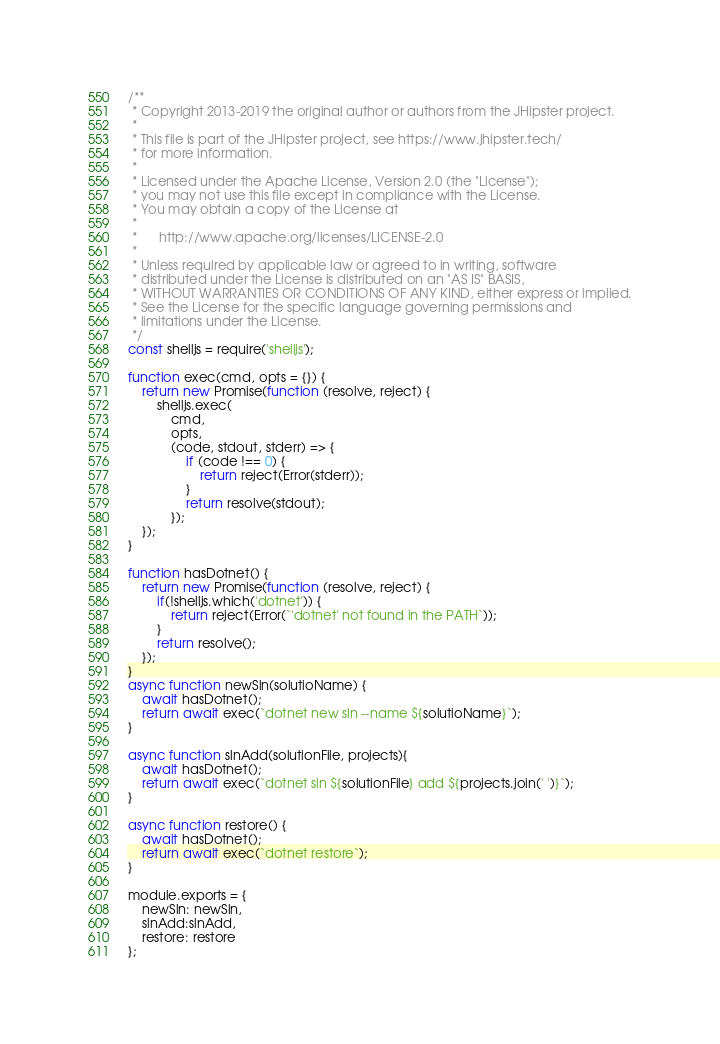Convert code to text. <code><loc_0><loc_0><loc_500><loc_500><_JavaScript_>/**
 * Copyright 2013-2019 the original author or authors from the JHipster project.
 *
 * This file is part of the JHipster project, see https://www.jhipster.tech/
 * for more information.
 *
 * Licensed under the Apache License, Version 2.0 (the "License");
 * you may not use this file except in compliance with the License.
 * You may obtain a copy of the License at
 *
 *      http://www.apache.org/licenses/LICENSE-2.0
 *
 * Unless required by applicable law or agreed to in writing, software
 * distributed under the License is distributed on an "AS IS" BASIS,
 * WITHOUT WARRANTIES OR CONDITIONS OF ANY KIND, either express or implied.
 * See the License for the specific language governing permissions and
 * limitations under the License.
 */
const shelljs = require('shelljs');

function exec(cmd, opts = {}) {
    return new Promise(function (resolve, reject) {
        shelljs.exec(
            cmd,
            opts,
            (code, stdout, stderr) => {
                if (code !== 0) {
                    return reject(Error(stderr));
                }
                return resolve(stdout);
            });
    });
}

function hasDotnet() {
    return new Promise(function (resolve, reject) {
        if(!shelljs.which('dotnet')) {
            return reject(Error(`'dotnet' not found in the PATH`));
        }
        return resolve();
    });
}
async function newSln(solutioName) {
    await hasDotnet();
    return await exec(`dotnet new sln --name ${solutioName}`);
}

async function slnAdd(solutionFile, projects){
    await hasDotnet();
    return await exec(`dotnet sln ${solutionFile} add ${projects.join(' ')}`);
}

async function restore() {
    await hasDotnet();
    return await exec(`dotnet restore`);
}

module.exports = {
    newSln: newSln,
    slnAdd:slnAdd,
    restore: restore
};
</code> 